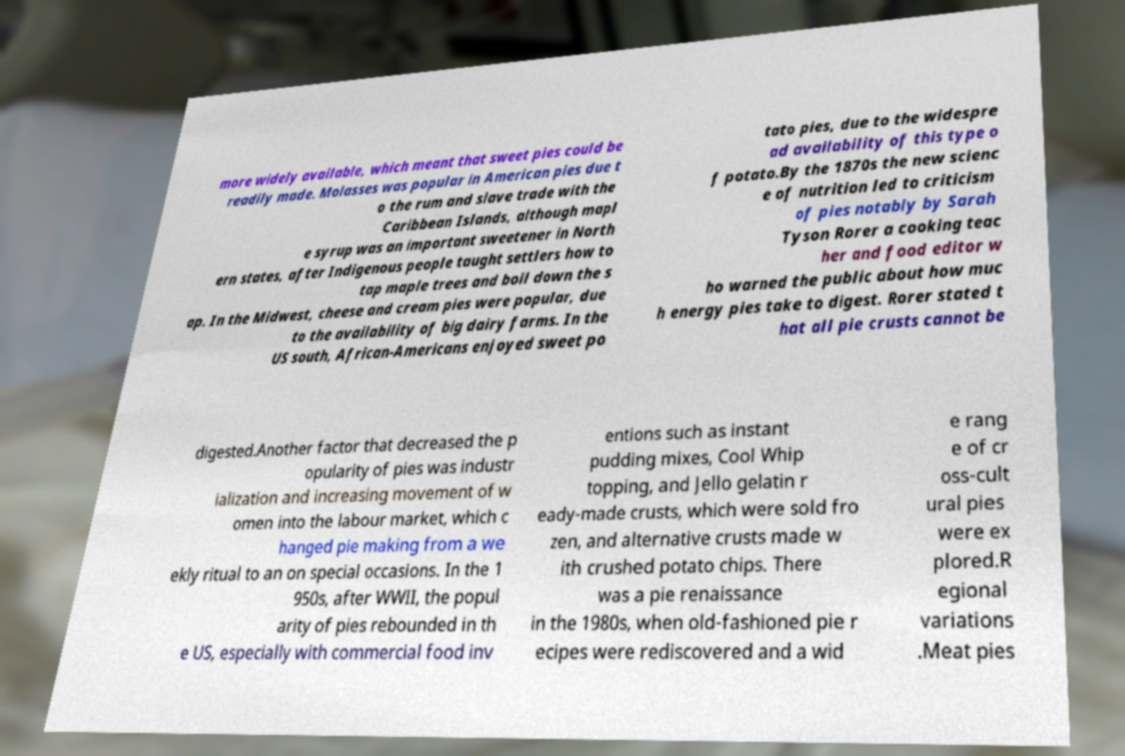Could you extract and type out the text from this image? more widely available, which meant that sweet pies could be readily made. Molasses was popular in American pies due t o the rum and slave trade with the Caribbean Islands, although mapl e syrup was an important sweetener in North ern states, after Indigenous people taught settlers how to tap maple trees and boil down the s ap. In the Midwest, cheese and cream pies were popular, due to the availability of big dairy farms. In the US south, African-Americans enjoyed sweet po tato pies, due to the widespre ad availability of this type o f potato.By the 1870s the new scienc e of nutrition led to criticism of pies notably by Sarah Tyson Rorer a cooking teac her and food editor w ho warned the public about how muc h energy pies take to digest. Rorer stated t hat all pie crusts cannot be digested.Another factor that decreased the p opularity of pies was industr ialization and increasing movement of w omen into the labour market, which c hanged pie making from a we ekly ritual to an on special occasions. In the 1 950s, after WWII, the popul arity of pies rebounded in th e US, especially with commercial food inv entions such as instant pudding mixes, Cool Whip topping, and Jello gelatin r eady-made crusts, which were sold fro zen, and alternative crusts made w ith crushed potato chips. There was a pie renaissance in the 1980s, when old-fashioned pie r ecipes were rediscovered and a wid e rang e of cr oss-cult ural pies were ex plored.R egional variations .Meat pies 